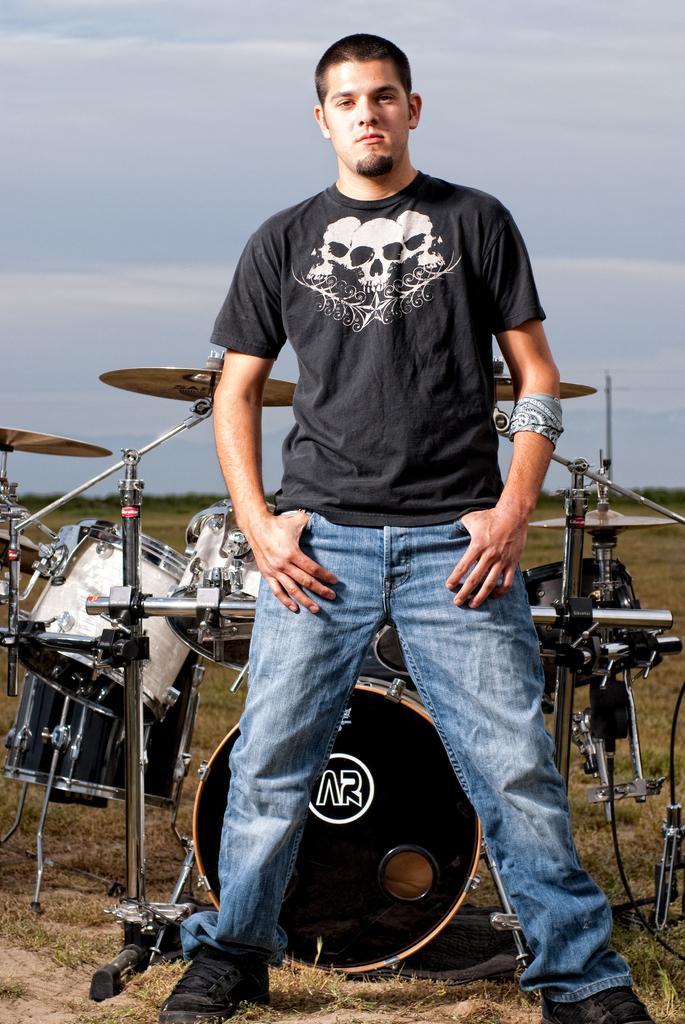Describe this image in one or two sentences. In this image there is one person who is standing and he is wearing black shirt and black shoes on the background there is sky on the bottom there is grass behind that person there are drums. 